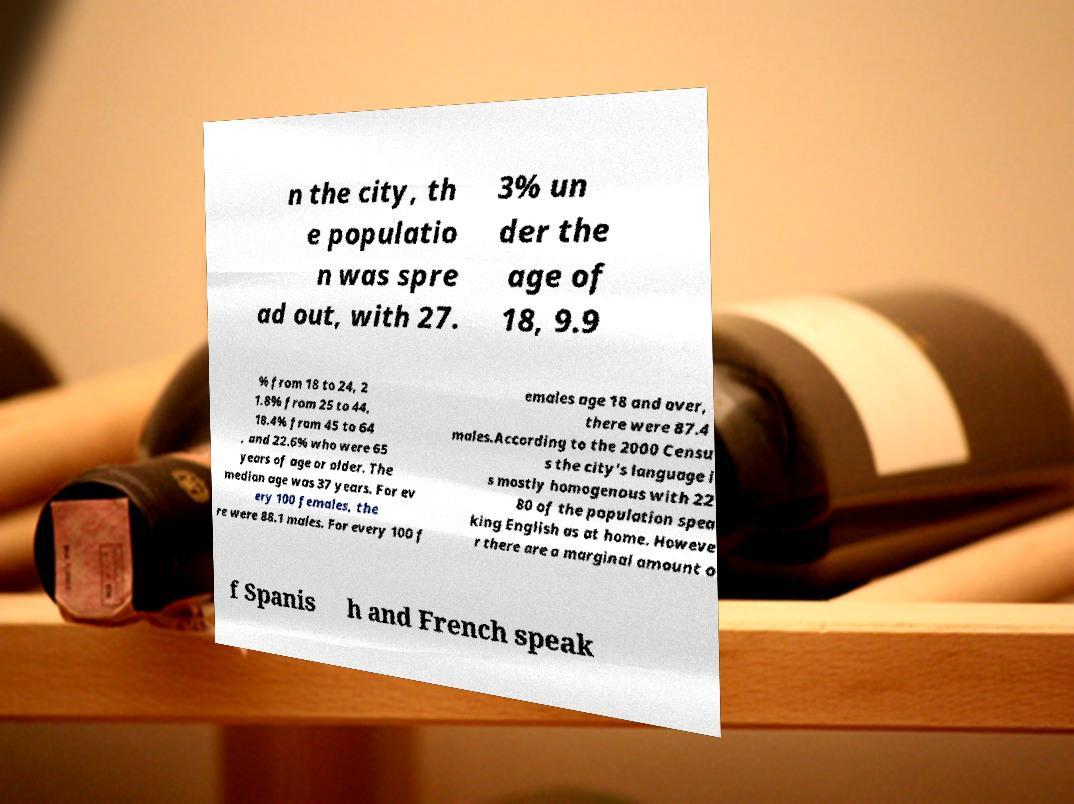Could you extract and type out the text from this image? n the city, th e populatio n was spre ad out, with 27. 3% un der the age of 18, 9.9 % from 18 to 24, 2 1.8% from 25 to 44, 18.4% from 45 to 64 , and 22.6% who were 65 years of age or older. The median age was 37 years. For ev ery 100 females, the re were 88.1 males. For every 100 f emales age 18 and over, there were 87.4 males.According to the 2000 Censu s the city's language i s mostly homogenous with 22 80 of the population spea king English as at home. Howeve r there are a marginal amount o f Spanis h and French speak 